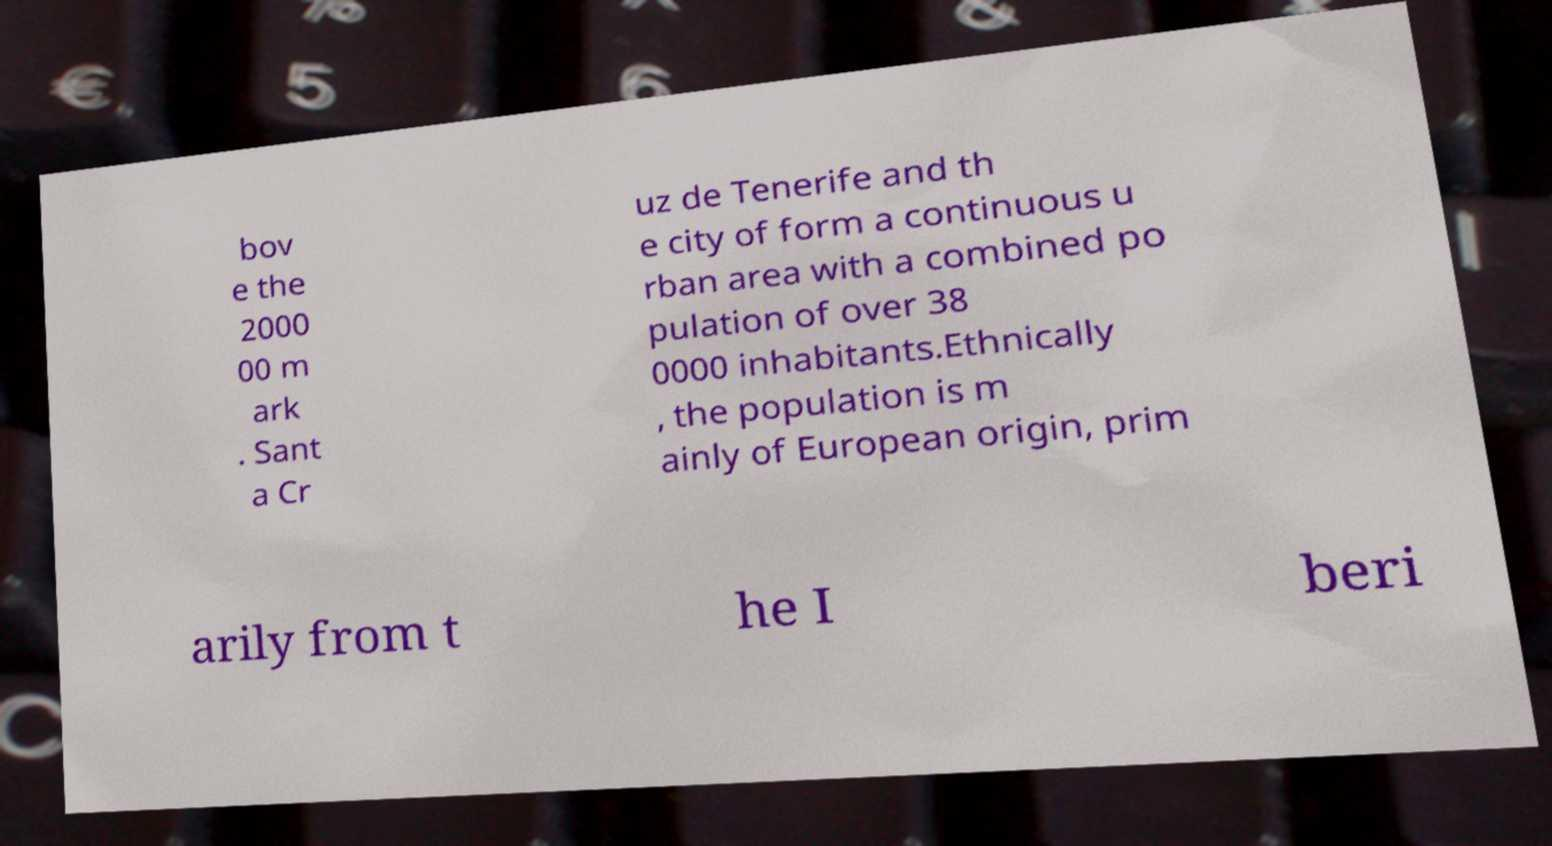Please identify and transcribe the text found in this image. bov e the 2000 00 m ark . Sant a Cr uz de Tenerife and th e city of form a continuous u rban area with a combined po pulation of over 38 0000 inhabitants.Ethnically , the population is m ainly of European origin, prim arily from t he I beri 